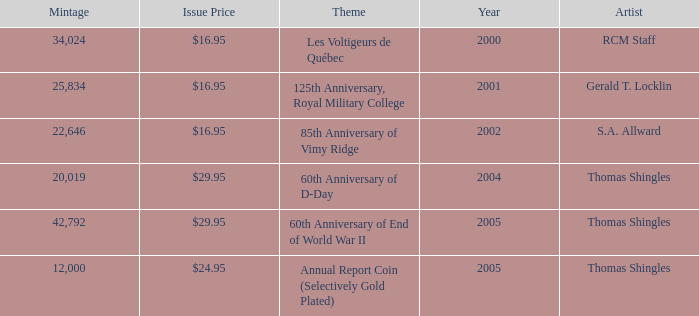What year was S.A. Allward's theme that had an issue price of $16.95 released? 2002.0. 